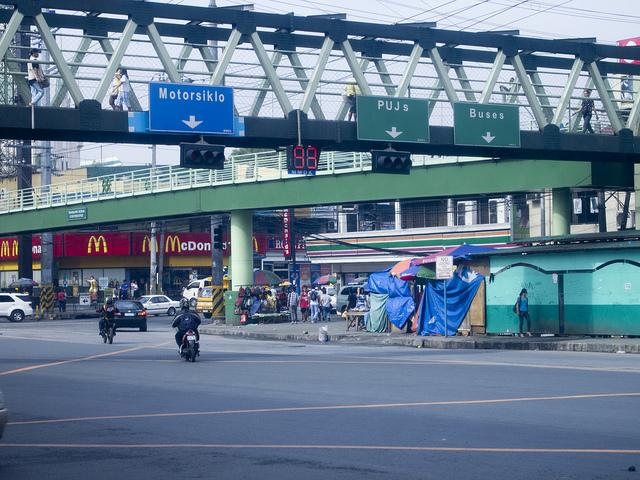What is the meaning of the arrows on the sign?

Choices:
A) merge left
B) one way
C) turn right
D) go straight go straight 